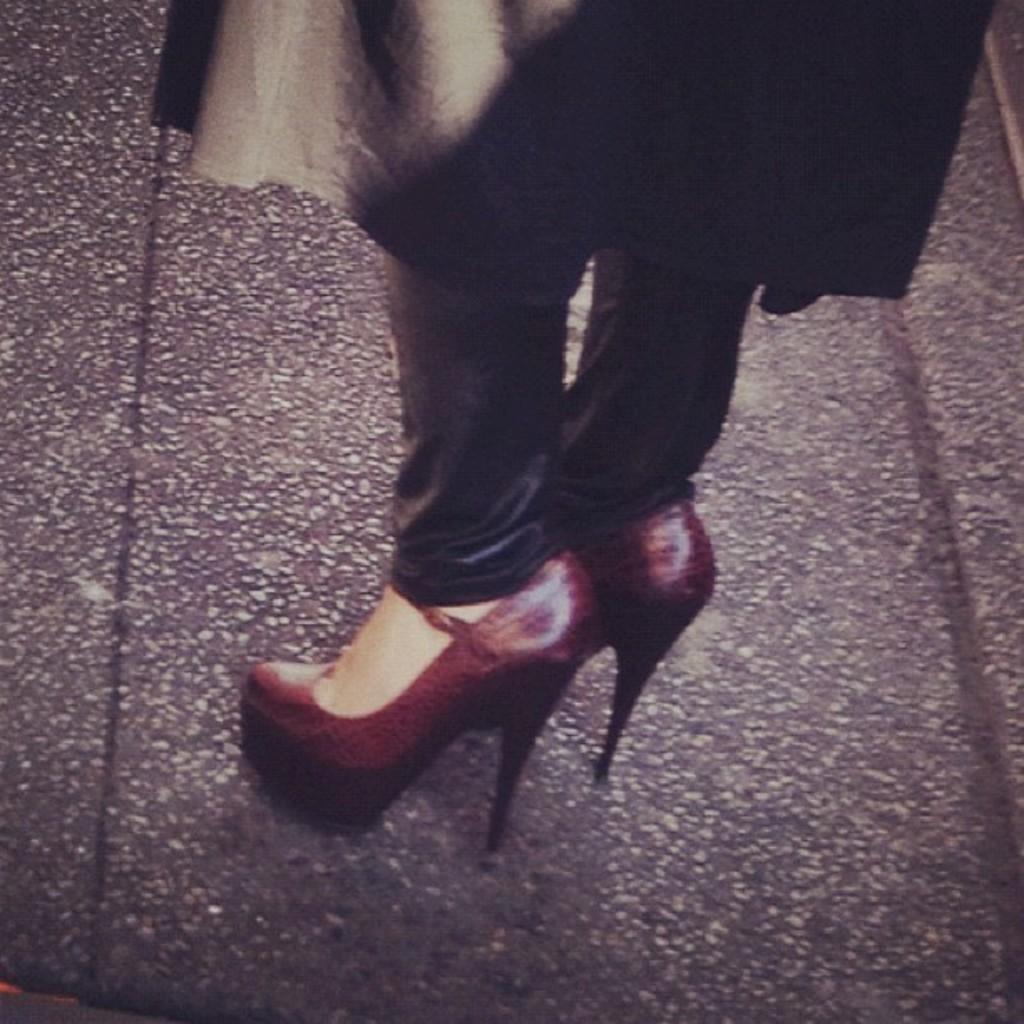Please provide a concise description of this image. Here I can see a person's legs wearing high heels and standing on the road. This person is wearing a black color dress. 